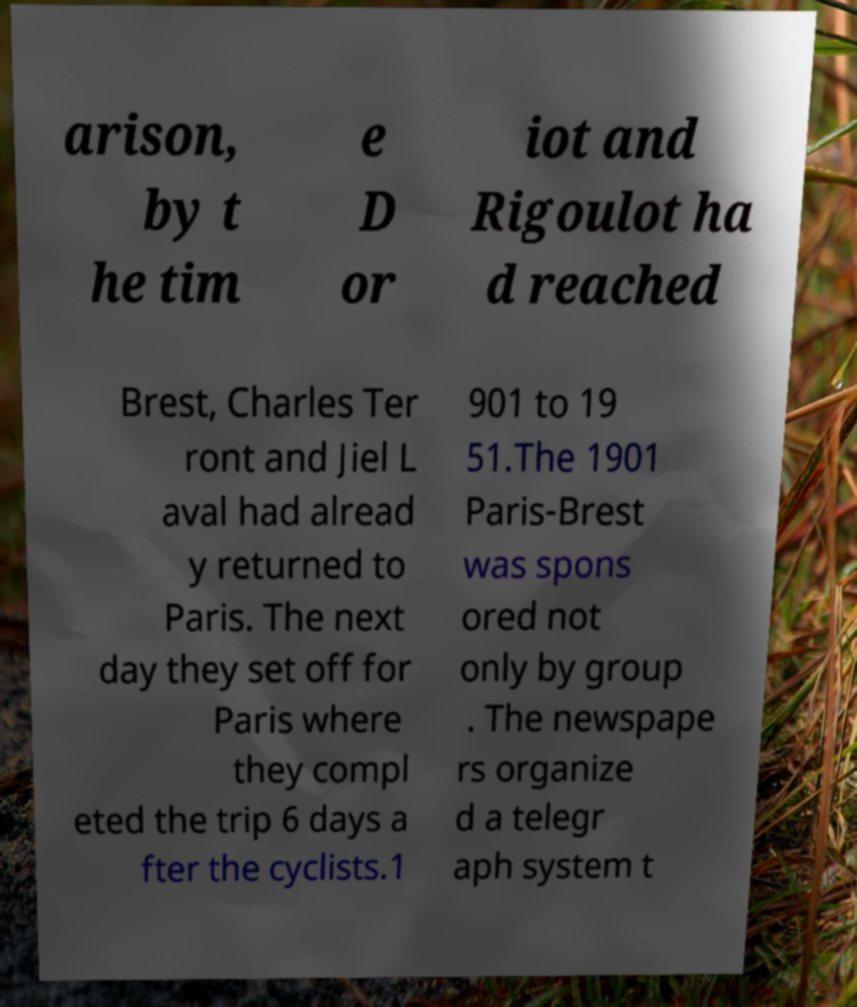Can you accurately transcribe the text from the provided image for me? arison, by t he tim e D or iot and Rigoulot ha d reached Brest, Charles Ter ront and Jiel L aval had alread y returned to Paris. The next day they set off for Paris where they compl eted the trip 6 days a fter the cyclists.1 901 to 19 51.The 1901 Paris-Brest was spons ored not only by group . The newspape rs organize d a telegr aph system t 